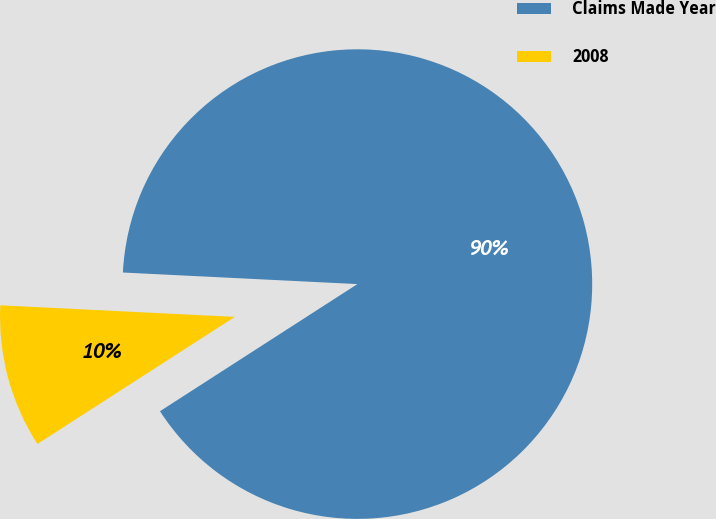<chart> <loc_0><loc_0><loc_500><loc_500><pie_chart><fcel>Claims Made Year<fcel>2008<nl><fcel>90.11%<fcel>9.89%<nl></chart> 